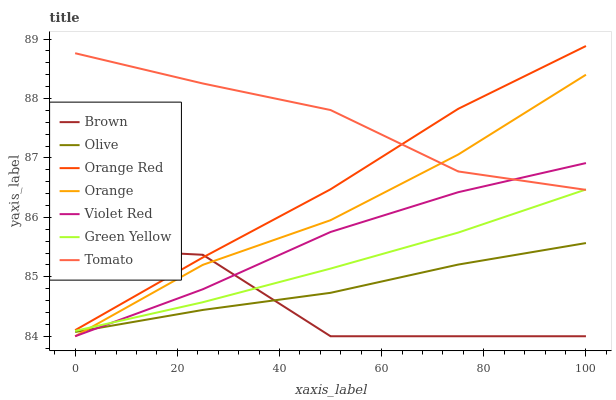Does Violet Red have the minimum area under the curve?
Answer yes or no. No. Does Violet Red have the maximum area under the curve?
Answer yes or no. No. Is Violet Red the smoothest?
Answer yes or no. No. Is Violet Red the roughest?
Answer yes or no. No. Does Olive have the lowest value?
Answer yes or no. No. Does Violet Red have the highest value?
Answer yes or no. No. Is Brown less than Tomato?
Answer yes or no. Yes. Is Orange Red greater than Green Yellow?
Answer yes or no. Yes. Does Brown intersect Tomato?
Answer yes or no. No. 